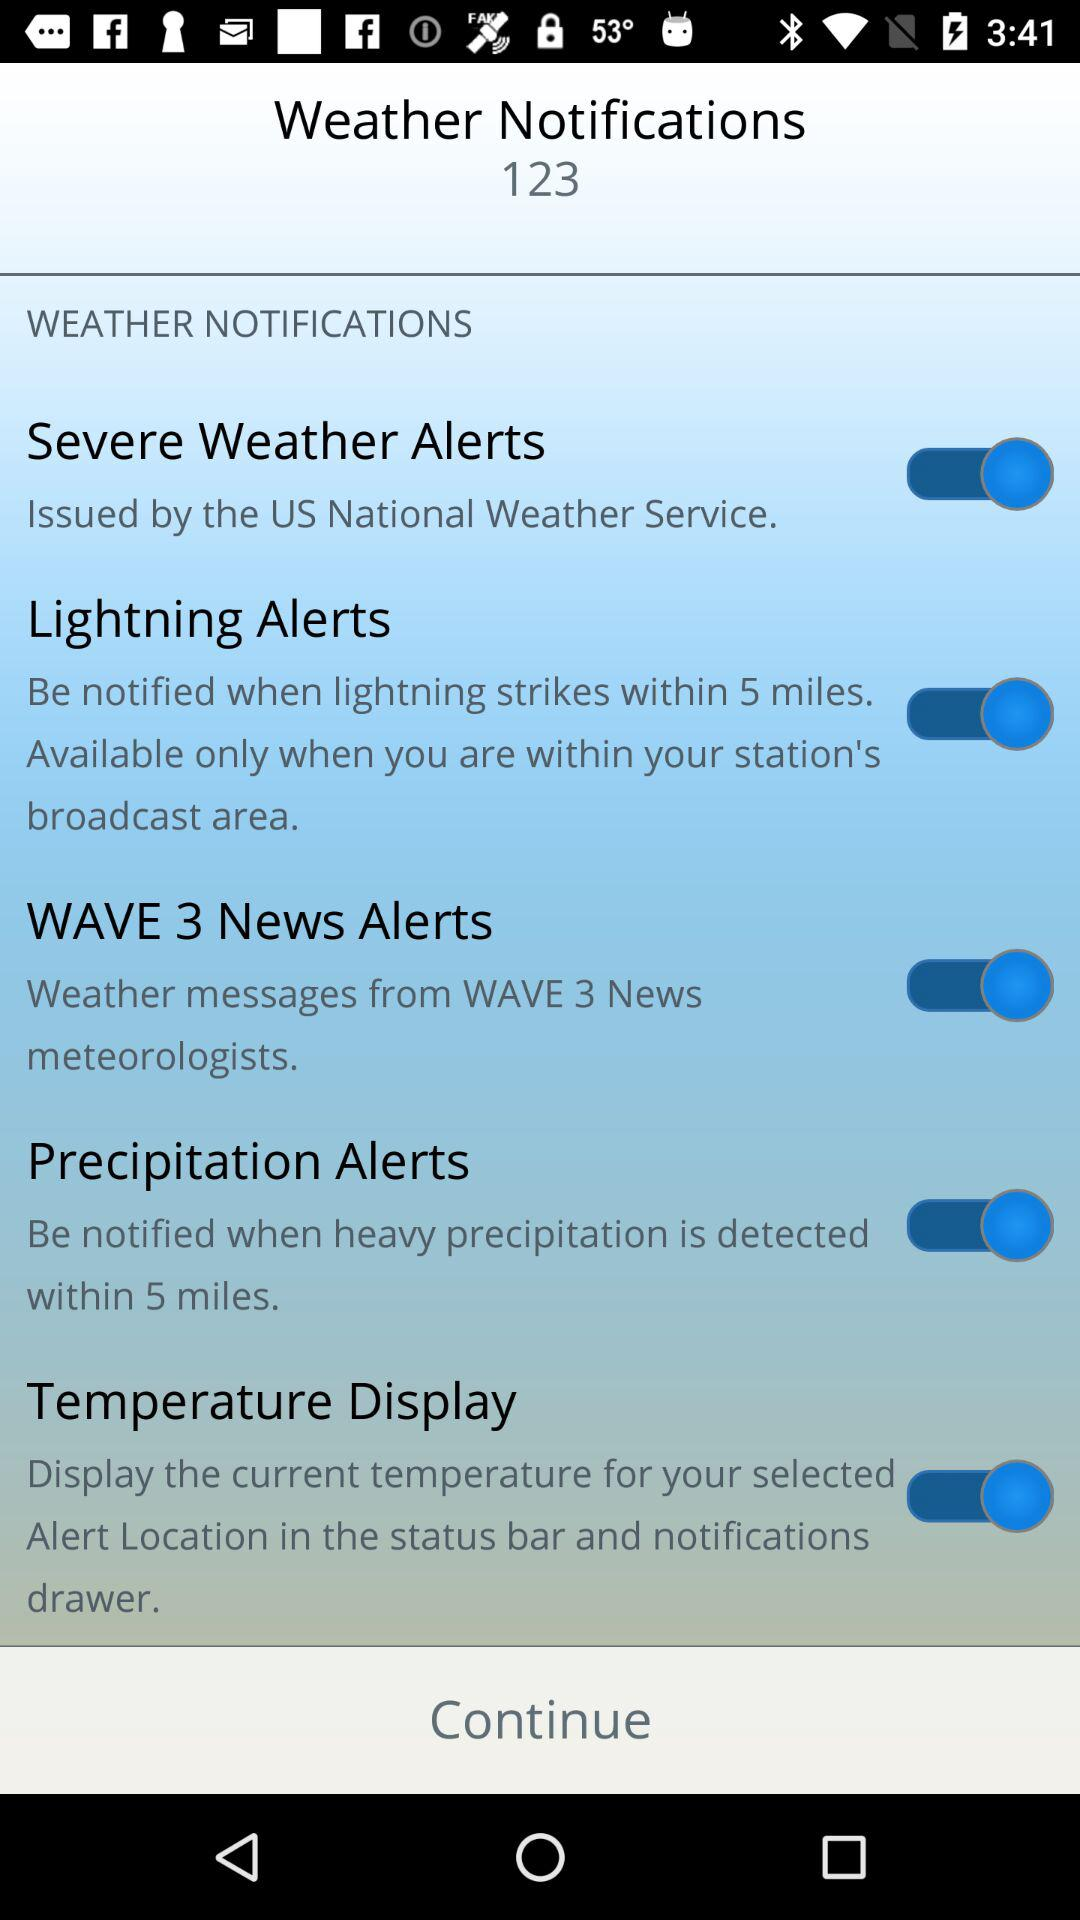What is the current status of the "Temperature Display"? The status is "on". 